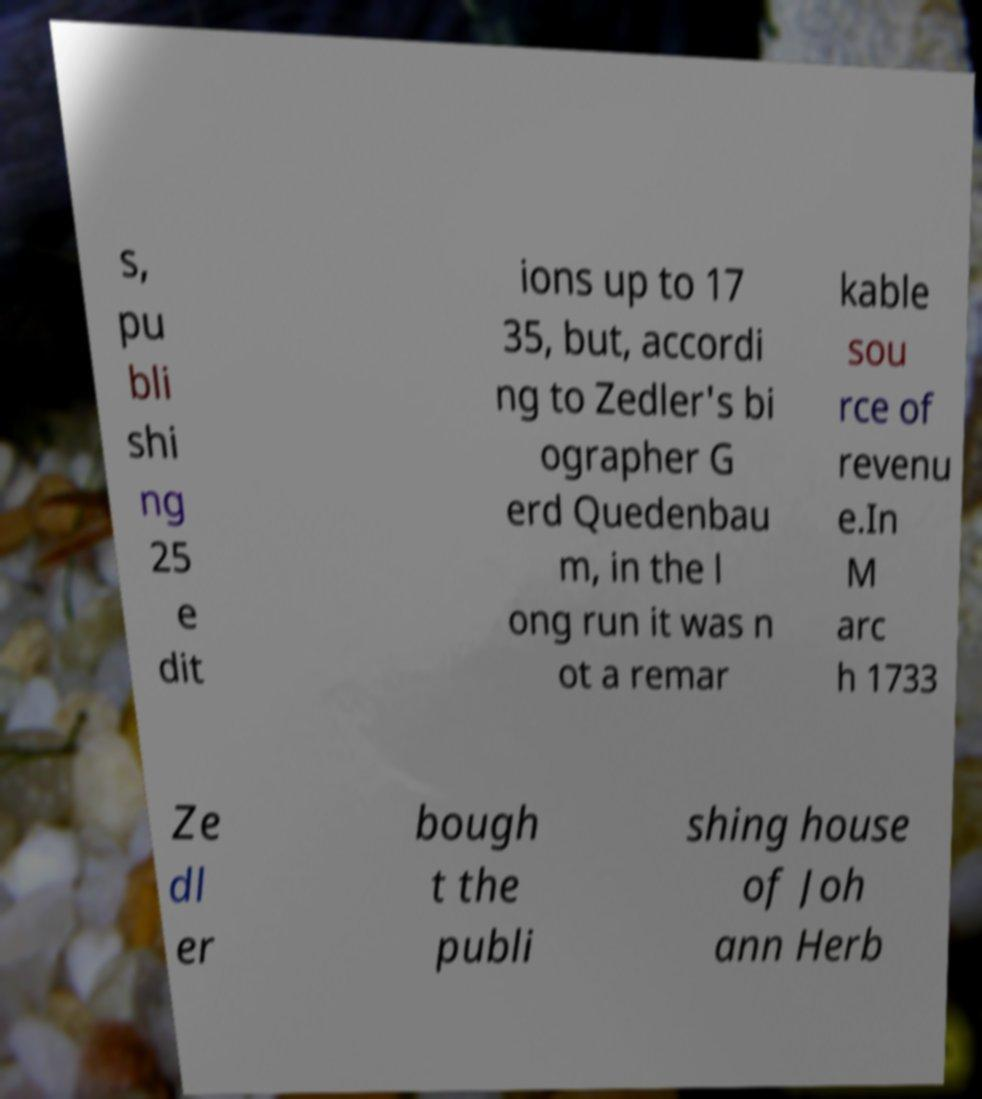Can you accurately transcribe the text from the provided image for me? s, pu bli shi ng 25 e dit ions up to 17 35, but, accordi ng to Zedler's bi ographer G erd Quedenbau m, in the l ong run it was n ot a remar kable sou rce of revenu e.In M arc h 1733 Ze dl er bough t the publi shing house of Joh ann Herb 